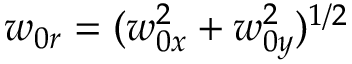<formula> <loc_0><loc_0><loc_500><loc_500>w _ { 0 r } = ( w _ { 0 x } ^ { 2 } + w _ { 0 y } ^ { 2 } ) ^ { 1 / 2 }</formula> 